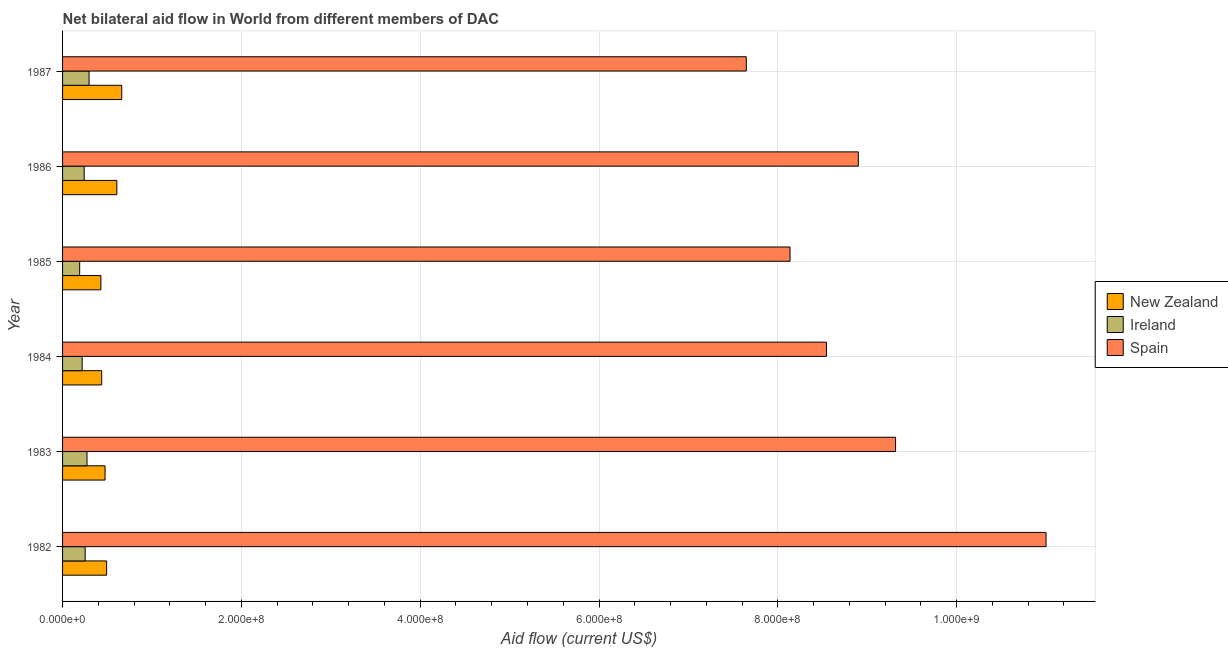How many different coloured bars are there?
Offer a very short reply. 3. How many groups of bars are there?
Your answer should be compact. 6. Are the number of bars per tick equal to the number of legend labels?
Provide a short and direct response. Yes. Are the number of bars on each tick of the Y-axis equal?
Your answer should be compact. Yes. What is the label of the 2nd group of bars from the top?
Give a very brief answer. 1986. What is the amount of aid provided by ireland in 1987?
Offer a very short reply. 2.96e+07. Across all years, what is the maximum amount of aid provided by spain?
Provide a succinct answer. 1.10e+09. Across all years, what is the minimum amount of aid provided by spain?
Your answer should be very brief. 7.65e+08. In which year was the amount of aid provided by ireland maximum?
Your response must be concise. 1987. In which year was the amount of aid provided by spain minimum?
Your answer should be very brief. 1987. What is the total amount of aid provided by ireland in the graph?
Offer a terse response. 1.47e+08. What is the difference between the amount of aid provided by spain in 1985 and that in 1986?
Your answer should be compact. -7.64e+07. What is the difference between the amount of aid provided by ireland in 1986 and the amount of aid provided by spain in 1983?
Your answer should be very brief. -9.08e+08. What is the average amount of aid provided by ireland per year?
Your answer should be very brief. 2.46e+07. In the year 1982, what is the difference between the amount of aid provided by spain and amount of aid provided by ireland?
Offer a terse response. 1.07e+09. In how many years, is the amount of aid provided by spain greater than 560000000 US$?
Offer a terse response. 6. What is the ratio of the amount of aid provided by ireland in 1982 to that in 1986?
Your answer should be compact. 1.05. Is the amount of aid provided by spain in 1982 less than that in 1985?
Offer a terse response. No. Is the difference between the amount of aid provided by spain in 1983 and 1985 greater than the difference between the amount of aid provided by ireland in 1983 and 1985?
Offer a very short reply. Yes. What is the difference between the highest and the second highest amount of aid provided by ireland?
Provide a succinct answer. 2.31e+06. What is the difference between the highest and the lowest amount of aid provided by ireland?
Your answer should be very brief. 1.05e+07. In how many years, is the amount of aid provided by new zealand greater than the average amount of aid provided by new zealand taken over all years?
Offer a very short reply. 2. What does the 1st bar from the top in 1982 represents?
Your response must be concise. Spain. What does the 2nd bar from the bottom in 1986 represents?
Your answer should be compact. Ireland. Is it the case that in every year, the sum of the amount of aid provided by new zealand and amount of aid provided by ireland is greater than the amount of aid provided by spain?
Offer a terse response. No. Are all the bars in the graph horizontal?
Ensure brevity in your answer.  Yes. How many years are there in the graph?
Provide a short and direct response. 6. Are the values on the major ticks of X-axis written in scientific E-notation?
Ensure brevity in your answer.  Yes. Where does the legend appear in the graph?
Ensure brevity in your answer.  Center right. How many legend labels are there?
Provide a short and direct response. 3. What is the title of the graph?
Offer a very short reply. Net bilateral aid flow in World from different members of DAC. Does "Maunufacturing" appear as one of the legend labels in the graph?
Your answer should be compact. No. What is the label or title of the X-axis?
Your answer should be very brief. Aid flow (current US$). What is the Aid flow (current US$) in New Zealand in 1982?
Keep it short and to the point. 4.93e+07. What is the Aid flow (current US$) of Ireland in 1982?
Give a very brief answer. 2.53e+07. What is the Aid flow (current US$) in Spain in 1982?
Offer a terse response. 1.10e+09. What is the Aid flow (current US$) in New Zealand in 1983?
Keep it short and to the point. 4.75e+07. What is the Aid flow (current US$) in Ireland in 1983?
Offer a terse response. 2.73e+07. What is the Aid flow (current US$) in Spain in 1983?
Your response must be concise. 9.32e+08. What is the Aid flow (current US$) in New Zealand in 1984?
Your answer should be compact. 4.38e+07. What is the Aid flow (current US$) in Ireland in 1984?
Offer a very short reply. 2.19e+07. What is the Aid flow (current US$) of Spain in 1984?
Your answer should be compact. 8.54e+08. What is the Aid flow (current US$) of New Zealand in 1985?
Ensure brevity in your answer.  4.28e+07. What is the Aid flow (current US$) in Ireland in 1985?
Your response must be concise. 1.91e+07. What is the Aid flow (current US$) of Spain in 1985?
Give a very brief answer. 8.14e+08. What is the Aid flow (current US$) in New Zealand in 1986?
Keep it short and to the point. 6.07e+07. What is the Aid flow (current US$) in Ireland in 1986?
Your response must be concise. 2.42e+07. What is the Aid flow (current US$) in Spain in 1986?
Offer a terse response. 8.90e+08. What is the Aid flow (current US$) in New Zealand in 1987?
Offer a terse response. 6.62e+07. What is the Aid flow (current US$) in Ireland in 1987?
Your answer should be very brief. 2.96e+07. What is the Aid flow (current US$) of Spain in 1987?
Make the answer very short. 7.65e+08. Across all years, what is the maximum Aid flow (current US$) of New Zealand?
Provide a succinct answer. 6.62e+07. Across all years, what is the maximum Aid flow (current US$) of Ireland?
Your answer should be very brief. 2.96e+07. Across all years, what is the maximum Aid flow (current US$) in Spain?
Provide a succinct answer. 1.10e+09. Across all years, what is the minimum Aid flow (current US$) of New Zealand?
Provide a succinct answer. 4.28e+07. Across all years, what is the minimum Aid flow (current US$) of Ireland?
Offer a very short reply. 1.91e+07. Across all years, what is the minimum Aid flow (current US$) of Spain?
Offer a terse response. 7.65e+08. What is the total Aid flow (current US$) of New Zealand in the graph?
Make the answer very short. 3.10e+08. What is the total Aid flow (current US$) in Ireland in the graph?
Ensure brevity in your answer.  1.47e+08. What is the total Aid flow (current US$) in Spain in the graph?
Offer a very short reply. 5.35e+09. What is the difference between the Aid flow (current US$) of New Zealand in 1982 and that in 1983?
Your response must be concise. 1.74e+06. What is the difference between the Aid flow (current US$) in Ireland in 1982 and that in 1983?
Keep it short and to the point. -2.05e+06. What is the difference between the Aid flow (current US$) in Spain in 1982 and that in 1983?
Provide a succinct answer. 1.68e+08. What is the difference between the Aid flow (current US$) of New Zealand in 1982 and that in 1984?
Offer a terse response. 5.49e+06. What is the difference between the Aid flow (current US$) in Ireland in 1982 and that in 1984?
Your response must be concise. 3.38e+06. What is the difference between the Aid flow (current US$) of Spain in 1982 and that in 1984?
Give a very brief answer. 2.46e+08. What is the difference between the Aid flow (current US$) of New Zealand in 1982 and that in 1985?
Provide a short and direct response. 6.43e+06. What is the difference between the Aid flow (current US$) in Ireland in 1982 and that in 1985?
Keep it short and to the point. 6.16e+06. What is the difference between the Aid flow (current US$) of Spain in 1982 and that in 1985?
Give a very brief answer. 2.86e+08. What is the difference between the Aid flow (current US$) in New Zealand in 1982 and that in 1986?
Give a very brief answer. -1.14e+07. What is the difference between the Aid flow (current US$) of Ireland in 1982 and that in 1986?
Ensure brevity in your answer.  1.13e+06. What is the difference between the Aid flow (current US$) in Spain in 1982 and that in 1986?
Provide a succinct answer. 2.10e+08. What is the difference between the Aid flow (current US$) in New Zealand in 1982 and that in 1987?
Offer a very short reply. -1.69e+07. What is the difference between the Aid flow (current US$) in Ireland in 1982 and that in 1987?
Provide a succinct answer. -4.36e+06. What is the difference between the Aid flow (current US$) of Spain in 1982 and that in 1987?
Ensure brevity in your answer.  3.35e+08. What is the difference between the Aid flow (current US$) in New Zealand in 1983 and that in 1984?
Offer a terse response. 3.75e+06. What is the difference between the Aid flow (current US$) in Ireland in 1983 and that in 1984?
Keep it short and to the point. 5.43e+06. What is the difference between the Aid flow (current US$) of Spain in 1983 and that in 1984?
Your answer should be compact. 7.73e+07. What is the difference between the Aid flow (current US$) in New Zealand in 1983 and that in 1985?
Your answer should be very brief. 4.69e+06. What is the difference between the Aid flow (current US$) in Ireland in 1983 and that in 1985?
Provide a succinct answer. 8.21e+06. What is the difference between the Aid flow (current US$) of Spain in 1983 and that in 1985?
Your response must be concise. 1.18e+08. What is the difference between the Aid flow (current US$) in New Zealand in 1983 and that in 1986?
Keep it short and to the point. -1.32e+07. What is the difference between the Aid flow (current US$) of Ireland in 1983 and that in 1986?
Ensure brevity in your answer.  3.18e+06. What is the difference between the Aid flow (current US$) of Spain in 1983 and that in 1986?
Provide a succinct answer. 4.17e+07. What is the difference between the Aid flow (current US$) of New Zealand in 1983 and that in 1987?
Your answer should be very brief. -1.86e+07. What is the difference between the Aid flow (current US$) of Ireland in 1983 and that in 1987?
Give a very brief answer. -2.31e+06. What is the difference between the Aid flow (current US$) of Spain in 1983 and that in 1987?
Provide a short and direct response. 1.67e+08. What is the difference between the Aid flow (current US$) of New Zealand in 1984 and that in 1985?
Your answer should be very brief. 9.40e+05. What is the difference between the Aid flow (current US$) in Ireland in 1984 and that in 1985?
Your answer should be very brief. 2.78e+06. What is the difference between the Aid flow (current US$) in Spain in 1984 and that in 1985?
Provide a succinct answer. 4.07e+07. What is the difference between the Aid flow (current US$) of New Zealand in 1984 and that in 1986?
Ensure brevity in your answer.  -1.69e+07. What is the difference between the Aid flow (current US$) in Ireland in 1984 and that in 1986?
Your response must be concise. -2.25e+06. What is the difference between the Aid flow (current US$) of Spain in 1984 and that in 1986?
Offer a very short reply. -3.56e+07. What is the difference between the Aid flow (current US$) of New Zealand in 1984 and that in 1987?
Keep it short and to the point. -2.24e+07. What is the difference between the Aid flow (current US$) in Ireland in 1984 and that in 1987?
Make the answer very short. -7.74e+06. What is the difference between the Aid flow (current US$) in Spain in 1984 and that in 1987?
Give a very brief answer. 8.97e+07. What is the difference between the Aid flow (current US$) of New Zealand in 1985 and that in 1986?
Your answer should be very brief. -1.79e+07. What is the difference between the Aid flow (current US$) of Ireland in 1985 and that in 1986?
Provide a short and direct response. -5.03e+06. What is the difference between the Aid flow (current US$) of Spain in 1985 and that in 1986?
Your answer should be very brief. -7.64e+07. What is the difference between the Aid flow (current US$) in New Zealand in 1985 and that in 1987?
Give a very brief answer. -2.33e+07. What is the difference between the Aid flow (current US$) of Ireland in 1985 and that in 1987?
Your answer should be very brief. -1.05e+07. What is the difference between the Aid flow (current US$) in Spain in 1985 and that in 1987?
Provide a short and direct response. 4.89e+07. What is the difference between the Aid flow (current US$) of New Zealand in 1986 and that in 1987?
Offer a terse response. -5.45e+06. What is the difference between the Aid flow (current US$) in Ireland in 1986 and that in 1987?
Offer a very short reply. -5.49e+06. What is the difference between the Aid flow (current US$) of Spain in 1986 and that in 1987?
Your answer should be compact. 1.25e+08. What is the difference between the Aid flow (current US$) in New Zealand in 1982 and the Aid flow (current US$) in Ireland in 1983?
Offer a very short reply. 2.19e+07. What is the difference between the Aid flow (current US$) in New Zealand in 1982 and the Aid flow (current US$) in Spain in 1983?
Your answer should be very brief. -8.82e+08. What is the difference between the Aid flow (current US$) of Ireland in 1982 and the Aid flow (current US$) of Spain in 1983?
Your answer should be very brief. -9.06e+08. What is the difference between the Aid flow (current US$) of New Zealand in 1982 and the Aid flow (current US$) of Ireland in 1984?
Offer a very short reply. 2.74e+07. What is the difference between the Aid flow (current US$) of New Zealand in 1982 and the Aid flow (current US$) of Spain in 1984?
Provide a short and direct response. -8.05e+08. What is the difference between the Aid flow (current US$) of Ireland in 1982 and the Aid flow (current US$) of Spain in 1984?
Keep it short and to the point. -8.29e+08. What is the difference between the Aid flow (current US$) in New Zealand in 1982 and the Aid flow (current US$) in Ireland in 1985?
Ensure brevity in your answer.  3.01e+07. What is the difference between the Aid flow (current US$) of New Zealand in 1982 and the Aid flow (current US$) of Spain in 1985?
Offer a terse response. -7.64e+08. What is the difference between the Aid flow (current US$) in Ireland in 1982 and the Aid flow (current US$) in Spain in 1985?
Offer a very short reply. -7.88e+08. What is the difference between the Aid flow (current US$) in New Zealand in 1982 and the Aid flow (current US$) in Ireland in 1986?
Keep it short and to the point. 2.51e+07. What is the difference between the Aid flow (current US$) of New Zealand in 1982 and the Aid flow (current US$) of Spain in 1986?
Provide a succinct answer. -8.41e+08. What is the difference between the Aid flow (current US$) in Ireland in 1982 and the Aid flow (current US$) in Spain in 1986?
Make the answer very short. -8.65e+08. What is the difference between the Aid flow (current US$) of New Zealand in 1982 and the Aid flow (current US$) of Ireland in 1987?
Keep it short and to the point. 1.96e+07. What is the difference between the Aid flow (current US$) of New Zealand in 1982 and the Aid flow (current US$) of Spain in 1987?
Your answer should be very brief. -7.15e+08. What is the difference between the Aid flow (current US$) in Ireland in 1982 and the Aid flow (current US$) in Spain in 1987?
Ensure brevity in your answer.  -7.39e+08. What is the difference between the Aid flow (current US$) of New Zealand in 1983 and the Aid flow (current US$) of Ireland in 1984?
Provide a short and direct response. 2.56e+07. What is the difference between the Aid flow (current US$) of New Zealand in 1983 and the Aid flow (current US$) of Spain in 1984?
Your response must be concise. -8.07e+08. What is the difference between the Aid flow (current US$) of Ireland in 1983 and the Aid flow (current US$) of Spain in 1984?
Your answer should be compact. -8.27e+08. What is the difference between the Aid flow (current US$) of New Zealand in 1983 and the Aid flow (current US$) of Ireland in 1985?
Keep it short and to the point. 2.84e+07. What is the difference between the Aid flow (current US$) of New Zealand in 1983 and the Aid flow (current US$) of Spain in 1985?
Provide a succinct answer. -7.66e+08. What is the difference between the Aid flow (current US$) of Ireland in 1983 and the Aid flow (current US$) of Spain in 1985?
Your answer should be very brief. -7.86e+08. What is the difference between the Aid flow (current US$) of New Zealand in 1983 and the Aid flow (current US$) of Ireland in 1986?
Your answer should be very brief. 2.34e+07. What is the difference between the Aid flow (current US$) in New Zealand in 1983 and the Aid flow (current US$) in Spain in 1986?
Give a very brief answer. -8.42e+08. What is the difference between the Aid flow (current US$) in Ireland in 1983 and the Aid flow (current US$) in Spain in 1986?
Your answer should be very brief. -8.63e+08. What is the difference between the Aid flow (current US$) of New Zealand in 1983 and the Aid flow (current US$) of Ireland in 1987?
Give a very brief answer. 1.79e+07. What is the difference between the Aid flow (current US$) of New Zealand in 1983 and the Aid flow (current US$) of Spain in 1987?
Your answer should be very brief. -7.17e+08. What is the difference between the Aid flow (current US$) of Ireland in 1983 and the Aid flow (current US$) of Spain in 1987?
Provide a short and direct response. -7.37e+08. What is the difference between the Aid flow (current US$) in New Zealand in 1984 and the Aid flow (current US$) in Ireland in 1985?
Provide a succinct answer. 2.46e+07. What is the difference between the Aid flow (current US$) in New Zealand in 1984 and the Aid flow (current US$) in Spain in 1985?
Keep it short and to the point. -7.70e+08. What is the difference between the Aid flow (current US$) in Ireland in 1984 and the Aid flow (current US$) in Spain in 1985?
Provide a short and direct response. -7.92e+08. What is the difference between the Aid flow (current US$) in New Zealand in 1984 and the Aid flow (current US$) in Ireland in 1986?
Provide a short and direct response. 1.96e+07. What is the difference between the Aid flow (current US$) in New Zealand in 1984 and the Aid flow (current US$) in Spain in 1986?
Offer a terse response. -8.46e+08. What is the difference between the Aid flow (current US$) in Ireland in 1984 and the Aid flow (current US$) in Spain in 1986?
Provide a succinct answer. -8.68e+08. What is the difference between the Aid flow (current US$) of New Zealand in 1984 and the Aid flow (current US$) of Ireland in 1987?
Give a very brief answer. 1.41e+07. What is the difference between the Aid flow (current US$) in New Zealand in 1984 and the Aid flow (current US$) in Spain in 1987?
Make the answer very short. -7.21e+08. What is the difference between the Aid flow (current US$) in Ireland in 1984 and the Aid flow (current US$) in Spain in 1987?
Your answer should be compact. -7.43e+08. What is the difference between the Aid flow (current US$) in New Zealand in 1985 and the Aid flow (current US$) in Ireland in 1986?
Make the answer very short. 1.87e+07. What is the difference between the Aid flow (current US$) in New Zealand in 1985 and the Aid flow (current US$) in Spain in 1986?
Ensure brevity in your answer.  -8.47e+08. What is the difference between the Aid flow (current US$) of Ireland in 1985 and the Aid flow (current US$) of Spain in 1986?
Make the answer very short. -8.71e+08. What is the difference between the Aid flow (current US$) of New Zealand in 1985 and the Aid flow (current US$) of Ireland in 1987?
Your answer should be compact. 1.32e+07. What is the difference between the Aid flow (current US$) of New Zealand in 1985 and the Aid flow (current US$) of Spain in 1987?
Your response must be concise. -7.22e+08. What is the difference between the Aid flow (current US$) in Ireland in 1985 and the Aid flow (current US$) in Spain in 1987?
Give a very brief answer. -7.46e+08. What is the difference between the Aid flow (current US$) of New Zealand in 1986 and the Aid flow (current US$) of Ireland in 1987?
Give a very brief answer. 3.11e+07. What is the difference between the Aid flow (current US$) in New Zealand in 1986 and the Aid flow (current US$) in Spain in 1987?
Provide a short and direct response. -7.04e+08. What is the difference between the Aid flow (current US$) of Ireland in 1986 and the Aid flow (current US$) of Spain in 1987?
Offer a very short reply. -7.41e+08. What is the average Aid flow (current US$) in New Zealand per year?
Your answer should be very brief. 5.17e+07. What is the average Aid flow (current US$) in Ireland per year?
Give a very brief answer. 2.46e+07. What is the average Aid flow (current US$) of Spain per year?
Your answer should be very brief. 8.92e+08. In the year 1982, what is the difference between the Aid flow (current US$) in New Zealand and Aid flow (current US$) in Ireland?
Give a very brief answer. 2.40e+07. In the year 1982, what is the difference between the Aid flow (current US$) in New Zealand and Aid flow (current US$) in Spain?
Provide a short and direct response. -1.05e+09. In the year 1982, what is the difference between the Aid flow (current US$) of Ireland and Aid flow (current US$) of Spain?
Provide a short and direct response. -1.07e+09. In the year 1983, what is the difference between the Aid flow (current US$) in New Zealand and Aid flow (current US$) in Ireland?
Provide a short and direct response. 2.02e+07. In the year 1983, what is the difference between the Aid flow (current US$) in New Zealand and Aid flow (current US$) in Spain?
Offer a terse response. -8.84e+08. In the year 1983, what is the difference between the Aid flow (current US$) of Ireland and Aid flow (current US$) of Spain?
Your answer should be very brief. -9.04e+08. In the year 1984, what is the difference between the Aid flow (current US$) in New Zealand and Aid flow (current US$) in Ireland?
Offer a very short reply. 2.19e+07. In the year 1984, what is the difference between the Aid flow (current US$) of New Zealand and Aid flow (current US$) of Spain?
Make the answer very short. -8.11e+08. In the year 1984, what is the difference between the Aid flow (current US$) in Ireland and Aid flow (current US$) in Spain?
Your response must be concise. -8.32e+08. In the year 1985, what is the difference between the Aid flow (current US$) of New Zealand and Aid flow (current US$) of Ireland?
Provide a succinct answer. 2.37e+07. In the year 1985, what is the difference between the Aid flow (current US$) in New Zealand and Aid flow (current US$) in Spain?
Provide a succinct answer. -7.71e+08. In the year 1985, what is the difference between the Aid flow (current US$) of Ireland and Aid flow (current US$) of Spain?
Make the answer very short. -7.95e+08. In the year 1986, what is the difference between the Aid flow (current US$) in New Zealand and Aid flow (current US$) in Ireland?
Offer a very short reply. 3.66e+07. In the year 1986, what is the difference between the Aid flow (current US$) of New Zealand and Aid flow (current US$) of Spain?
Your response must be concise. -8.29e+08. In the year 1986, what is the difference between the Aid flow (current US$) in Ireland and Aid flow (current US$) in Spain?
Make the answer very short. -8.66e+08. In the year 1987, what is the difference between the Aid flow (current US$) in New Zealand and Aid flow (current US$) in Ireland?
Make the answer very short. 3.65e+07. In the year 1987, what is the difference between the Aid flow (current US$) of New Zealand and Aid flow (current US$) of Spain?
Give a very brief answer. -6.99e+08. In the year 1987, what is the difference between the Aid flow (current US$) in Ireland and Aid flow (current US$) in Spain?
Provide a succinct answer. -7.35e+08. What is the ratio of the Aid flow (current US$) in New Zealand in 1982 to that in 1983?
Your answer should be very brief. 1.04. What is the ratio of the Aid flow (current US$) of Ireland in 1982 to that in 1983?
Your response must be concise. 0.93. What is the ratio of the Aid flow (current US$) in Spain in 1982 to that in 1983?
Offer a terse response. 1.18. What is the ratio of the Aid flow (current US$) of New Zealand in 1982 to that in 1984?
Offer a terse response. 1.13. What is the ratio of the Aid flow (current US$) of Ireland in 1982 to that in 1984?
Provide a short and direct response. 1.15. What is the ratio of the Aid flow (current US$) of Spain in 1982 to that in 1984?
Offer a very short reply. 1.29. What is the ratio of the Aid flow (current US$) of New Zealand in 1982 to that in 1985?
Provide a succinct answer. 1.15. What is the ratio of the Aid flow (current US$) of Ireland in 1982 to that in 1985?
Your answer should be very brief. 1.32. What is the ratio of the Aid flow (current US$) in Spain in 1982 to that in 1985?
Ensure brevity in your answer.  1.35. What is the ratio of the Aid flow (current US$) of New Zealand in 1982 to that in 1986?
Keep it short and to the point. 0.81. What is the ratio of the Aid flow (current US$) in Ireland in 1982 to that in 1986?
Give a very brief answer. 1.05. What is the ratio of the Aid flow (current US$) of Spain in 1982 to that in 1986?
Your answer should be compact. 1.24. What is the ratio of the Aid flow (current US$) of New Zealand in 1982 to that in 1987?
Your answer should be compact. 0.74. What is the ratio of the Aid flow (current US$) of Ireland in 1982 to that in 1987?
Provide a succinct answer. 0.85. What is the ratio of the Aid flow (current US$) in Spain in 1982 to that in 1987?
Your response must be concise. 1.44. What is the ratio of the Aid flow (current US$) of New Zealand in 1983 to that in 1984?
Your answer should be compact. 1.09. What is the ratio of the Aid flow (current US$) of Ireland in 1983 to that in 1984?
Give a very brief answer. 1.25. What is the ratio of the Aid flow (current US$) of Spain in 1983 to that in 1984?
Ensure brevity in your answer.  1.09. What is the ratio of the Aid flow (current US$) in New Zealand in 1983 to that in 1985?
Ensure brevity in your answer.  1.11. What is the ratio of the Aid flow (current US$) in Ireland in 1983 to that in 1985?
Your answer should be compact. 1.43. What is the ratio of the Aid flow (current US$) in Spain in 1983 to that in 1985?
Provide a succinct answer. 1.15. What is the ratio of the Aid flow (current US$) of New Zealand in 1983 to that in 1986?
Make the answer very short. 0.78. What is the ratio of the Aid flow (current US$) in Ireland in 1983 to that in 1986?
Offer a very short reply. 1.13. What is the ratio of the Aid flow (current US$) of Spain in 1983 to that in 1986?
Make the answer very short. 1.05. What is the ratio of the Aid flow (current US$) in New Zealand in 1983 to that in 1987?
Give a very brief answer. 0.72. What is the ratio of the Aid flow (current US$) of Ireland in 1983 to that in 1987?
Offer a very short reply. 0.92. What is the ratio of the Aid flow (current US$) of Spain in 1983 to that in 1987?
Provide a short and direct response. 1.22. What is the ratio of the Aid flow (current US$) in New Zealand in 1984 to that in 1985?
Your answer should be compact. 1.02. What is the ratio of the Aid flow (current US$) in Ireland in 1984 to that in 1985?
Offer a terse response. 1.15. What is the ratio of the Aid flow (current US$) of Spain in 1984 to that in 1985?
Ensure brevity in your answer.  1.05. What is the ratio of the Aid flow (current US$) of New Zealand in 1984 to that in 1986?
Ensure brevity in your answer.  0.72. What is the ratio of the Aid flow (current US$) in Ireland in 1984 to that in 1986?
Provide a short and direct response. 0.91. What is the ratio of the Aid flow (current US$) of Spain in 1984 to that in 1986?
Offer a very short reply. 0.96. What is the ratio of the Aid flow (current US$) of New Zealand in 1984 to that in 1987?
Keep it short and to the point. 0.66. What is the ratio of the Aid flow (current US$) of Ireland in 1984 to that in 1987?
Make the answer very short. 0.74. What is the ratio of the Aid flow (current US$) in Spain in 1984 to that in 1987?
Ensure brevity in your answer.  1.12. What is the ratio of the Aid flow (current US$) of New Zealand in 1985 to that in 1986?
Your answer should be compact. 0.71. What is the ratio of the Aid flow (current US$) in Ireland in 1985 to that in 1986?
Provide a succinct answer. 0.79. What is the ratio of the Aid flow (current US$) in Spain in 1985 to that in 1986?
Your response must be concise. 0.91. What is the ratio of the Aid flow (current US$) of New Zealand in 1985 to that in 1987?
Provide a short and direct response. 0.65. What is the ratio of the Aid flow (current US$) in Ireland in 1985 to that in 1987?
Ensure brevity in your answer.  0.65. What is the ratio of the Aid flow (current US$) in Spain in 1985 to that in 1987?
Give a very brief answer. 1.06. What is the ratio of the Aid flow (current US$) in New Zealand in 1986 to that in 1987?
Give a very brief answer. 0.92. What is the ratio of the Aid flow (current US$) in Ireland in 1986 to that in 1987?
Provide a succinct answer. 0.81. What is the ratio of the Aid flow (current US$) of Spain in 1986 to that in 1987?
Make the answer very short. 1.16. What is the difference between the highest and the second highest Aid flow (current US$) in New Zealand?
Provide a succinct answer. 5.45e+06. What is the difference between the highest and the second highest Aid flow (current US$) in Ireland?
Offer a terse response. 2.31e+06. What is the difference between the highest and the second highest Aid flow (current US$) in Spain?
Ensure brevity in your answer.  1.68e+08. What is the difference between the highest and the lowest Aid flow (current US$) of New Zealand?
Your answer should be very brief. 2.33e+07. What is the difference between the highest and the lowest Aid flow (current US$) in Ireland?
Provide a short and direct response. 1.05e+07. What is the difference between the highest and the lowest Aid flow (current US$) in Spain?
Your answer should be compact. 3.35e+08. 